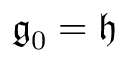Convert formula to latex. <formula><loc_0><loc_0><loc_500><loc_500>{ \mathfrak { g } } _ { 0 } = { \mathfrak { h } }</formula> 